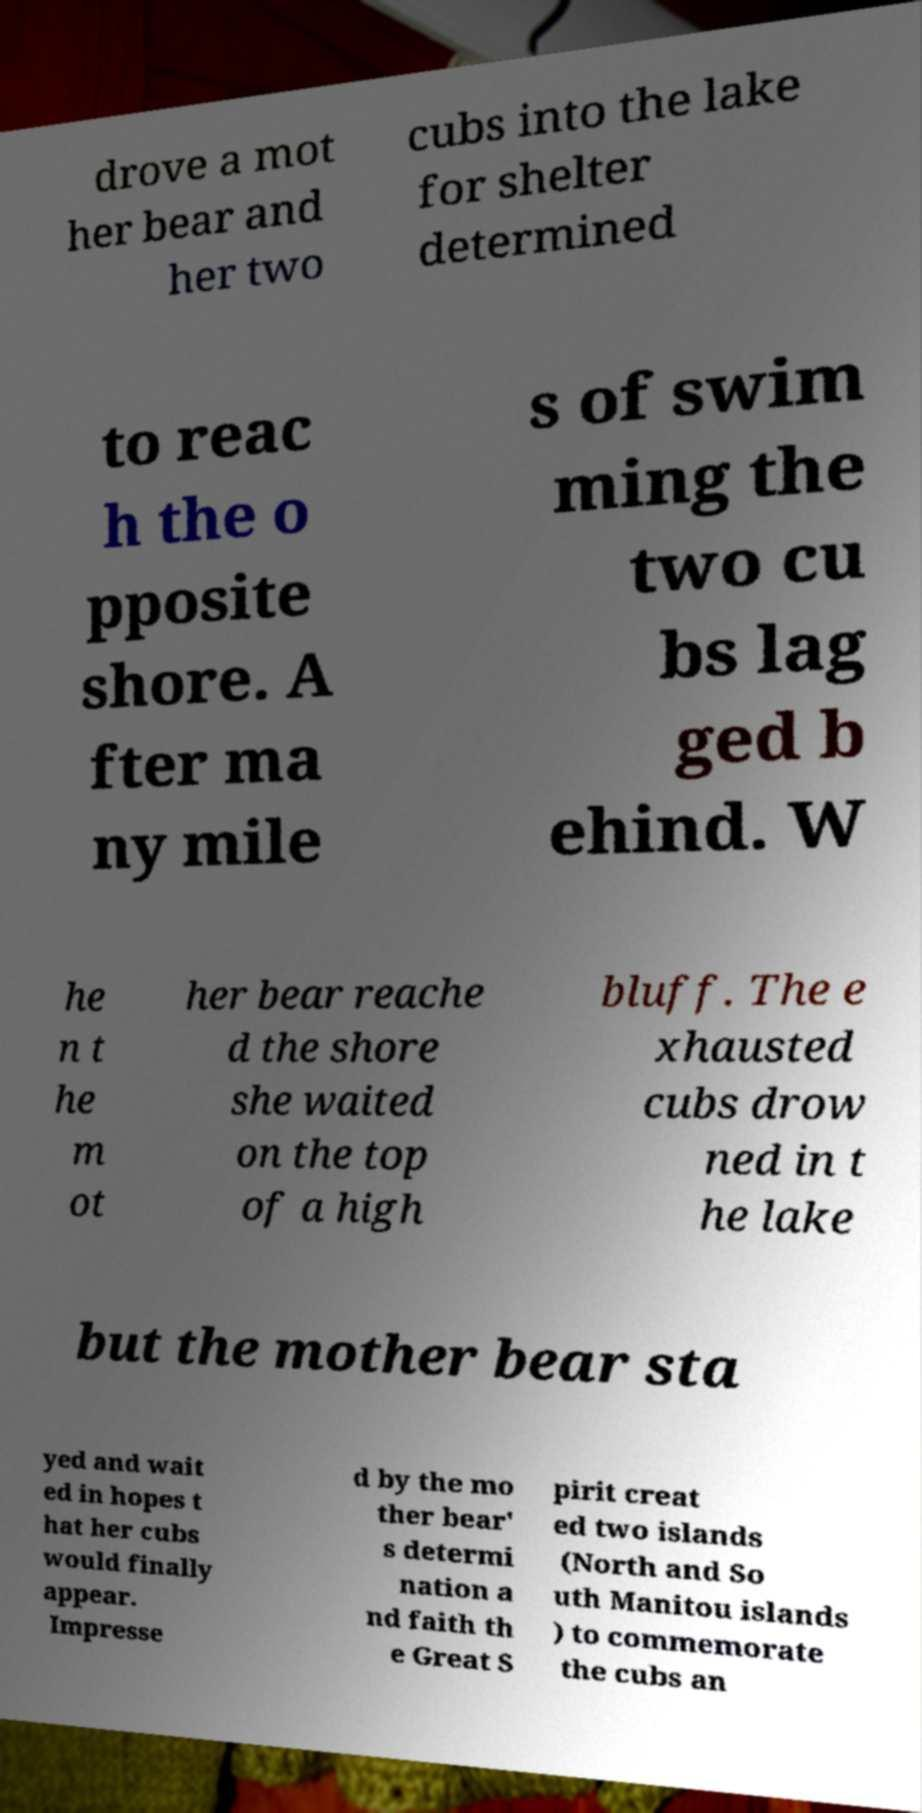I need the written content from this picture converted into text. Can you do that? drove a mot her bear and her two cubs into the lake for shelter determined to reac h the o pposite shore. A fter ma ny mile s of swim ming the two cu bs lag ged b ehind. W he n t he m ot her bear reache d the shore she waited on the top of a high bluff. The e xhausted cubs drow ned in t he lake but the mother bear sta yed and wait ed in hopes t hat her cubs would finally appear. Impresse d by the mo ther bear' s determi nation a nd faith th e Great S pirit creat ed two islands (North and So uth Manitou islands ) to commemorate the cubs an 